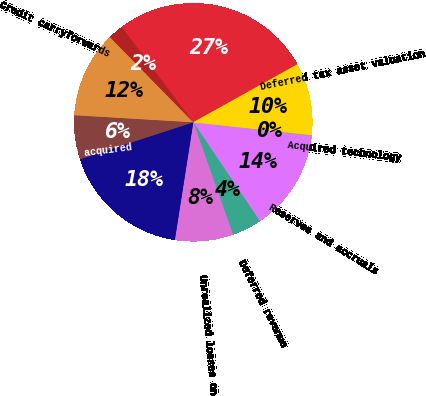<chart> <loc_0><loc_0><loc_500><loc_500><pie_chart><fcel>Acquired technology<fcel>Reserves and accruals<fcel>Deferred revenue<fcel>Unrealized losses on<fcel>Stock-based compensation<fcel>Net operating loss of acquired<fcel>Credit carryforwards<fcel>Other<fcel>Total gross deferred tax<fcel>Deferred tax asset valuation<nl><fcel>0.18%<fcel>13.66%<fcel>4.03%<fcel>7.88%<fcel>17.51%<fcel>5.96%<fcel>11.73%<fcel>2.1%<fcel>27.14%<fcel>9.81%<nl></chart> 